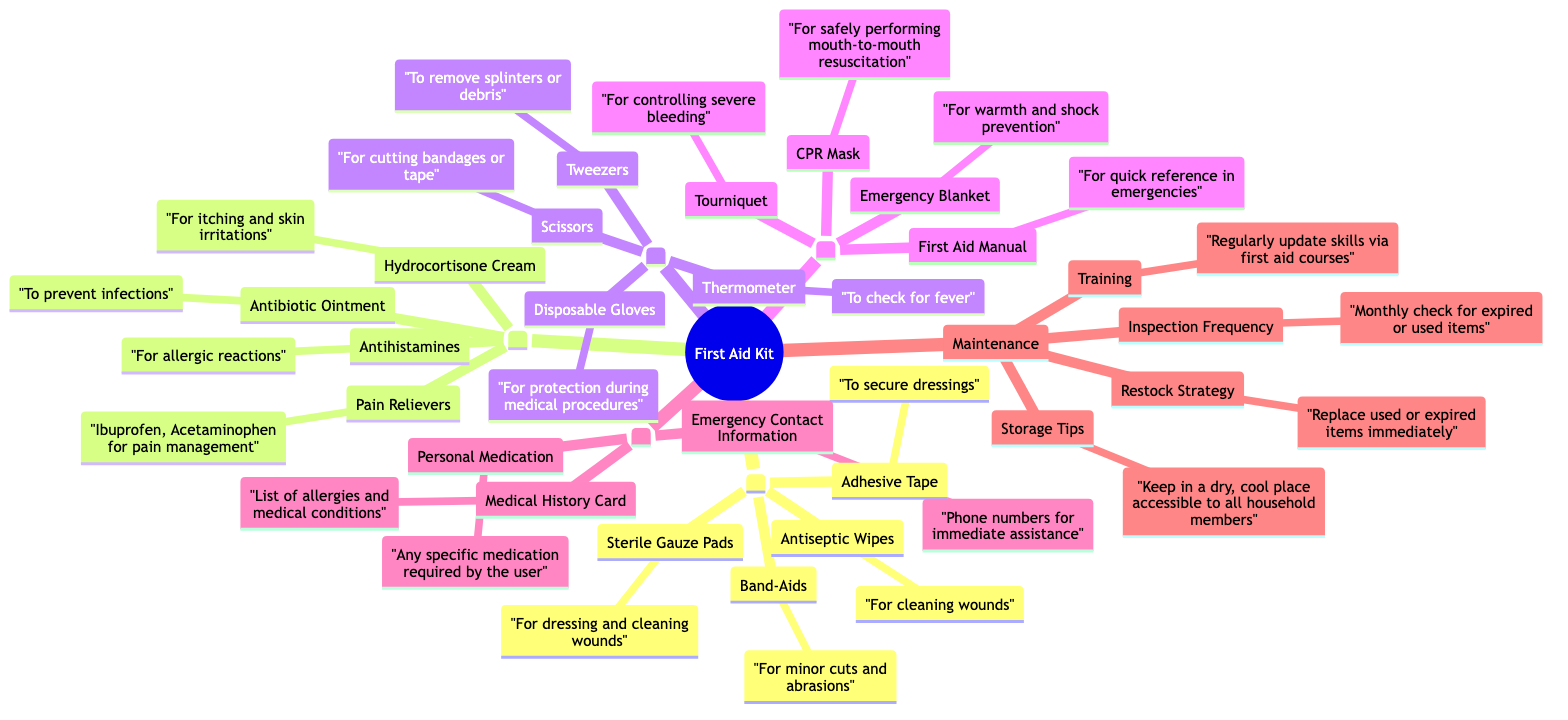What is the first category listed in the diagram? The first category under "Preparation and Maintenance of a First Aid Kit" is labeled "1. Basic Supplies," which is identified by the numbering.
Answer: 1. Basic Supplies How many medication items are listed? The "Medication" category contains four items: Pain Relievers, Antibiotic Ointment, Antihistamines, and Hydrocortisone Cream. Counting these gives a total of four.
Answer: 4 What is the use of Adhesive Tape? Under the "Basic Supplies" category, the description for Adhesive Tape is provided as "To secure dressings," which directly defines its use.
Answer: To secure dressings Which item is used for controlling severe bleeding? The item that serves the purpose of controlling severe bleeding is "Tourniquet," located within the "Emergency Items" category.
Answer: Tourniquet What is the storage tip for the first aid kit? The maintenance section includes the tip "Keep in a dry, cool place accessible to all household members," serving as a guideline for storage.
Answer: Keep in a dry, cool place accessible to all household members What should you do if an item in the kit is used? The restock strategy states to "Replace used or expired items immediately," emphasizing the importance of timely replenishment.
Answer: Replace used or expired items immediately Which two items are listed under "Personal Items"? In the "Personal Items" category, two items are specified: "Personal Medication" and "Medical History Card," which summarizing their importance in this section.
Answer: Personal Medication and Medical History Card How often should inspection occur? The maintenance section clearly states the frequency for inspections as "Monthly check for expired or used items," defining a regular interval for this activity.
Answer: Monthly check for expired or used items What is the purpose of the First Aid Manual? The First Aid Manual, categorized under "Emergency Items," is intended to serve as "quick reference in emergencies," stating its functional purpose.
Answer: quick reference in emergencies 